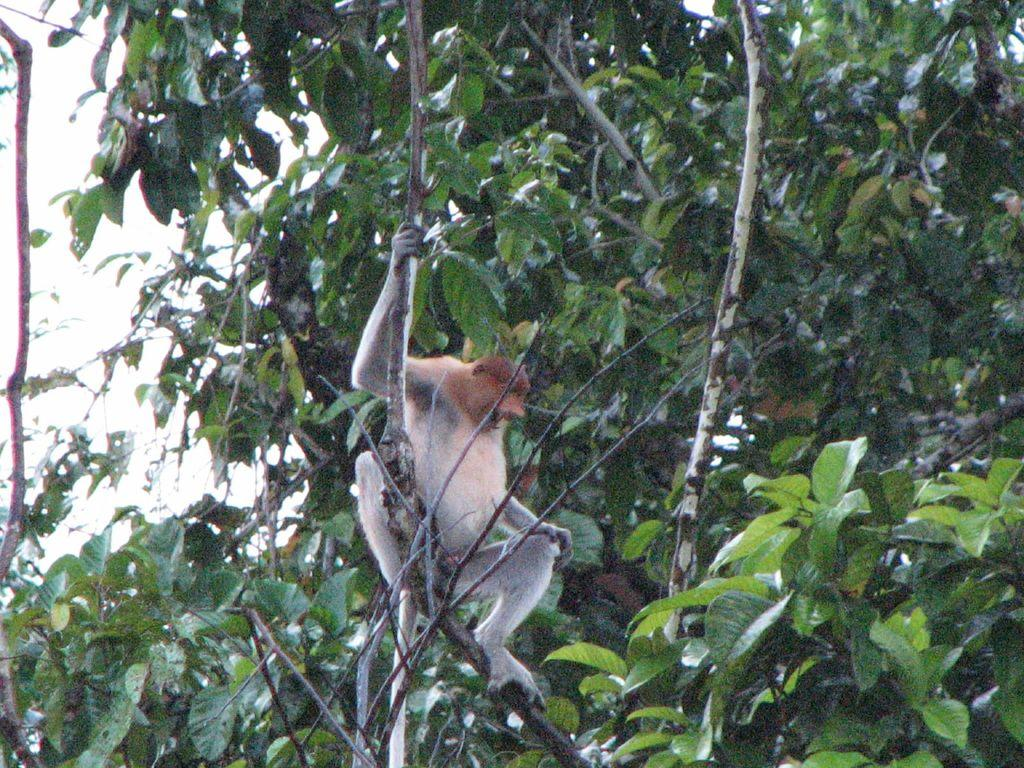What animal is in the image? There is a monkey in the image. Where is the monkey located? The monkey is sitting on a tree. What else can be seen in the image besides the monkey? There is a tree in the background of the image. What is visible at the top of the image? The sky is visible at the top of the image. What type of education does the robin in the image have? There is no robin present in the image; it features a monkey sitting on a tree. How many thumbs does the monkey have in the image? Monkeys typically have two thumbs, but the image does not show the monkey's hands or thumbs. 